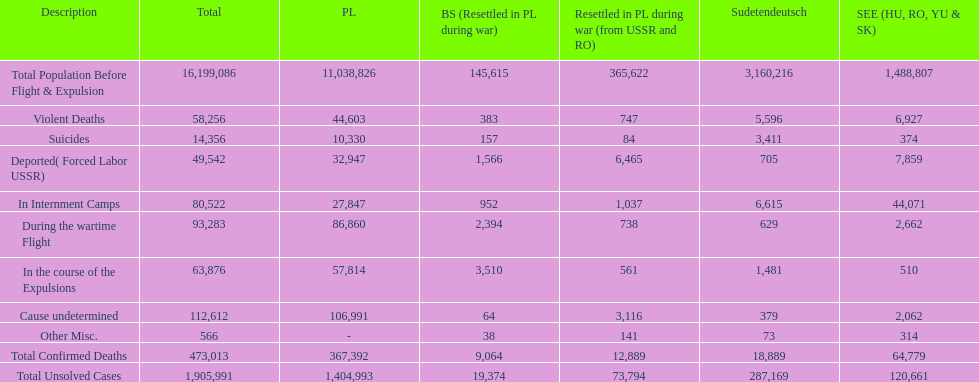Were there more cause undetermined or miscellaneous deaths in the baltic states? Cause undetermined. 